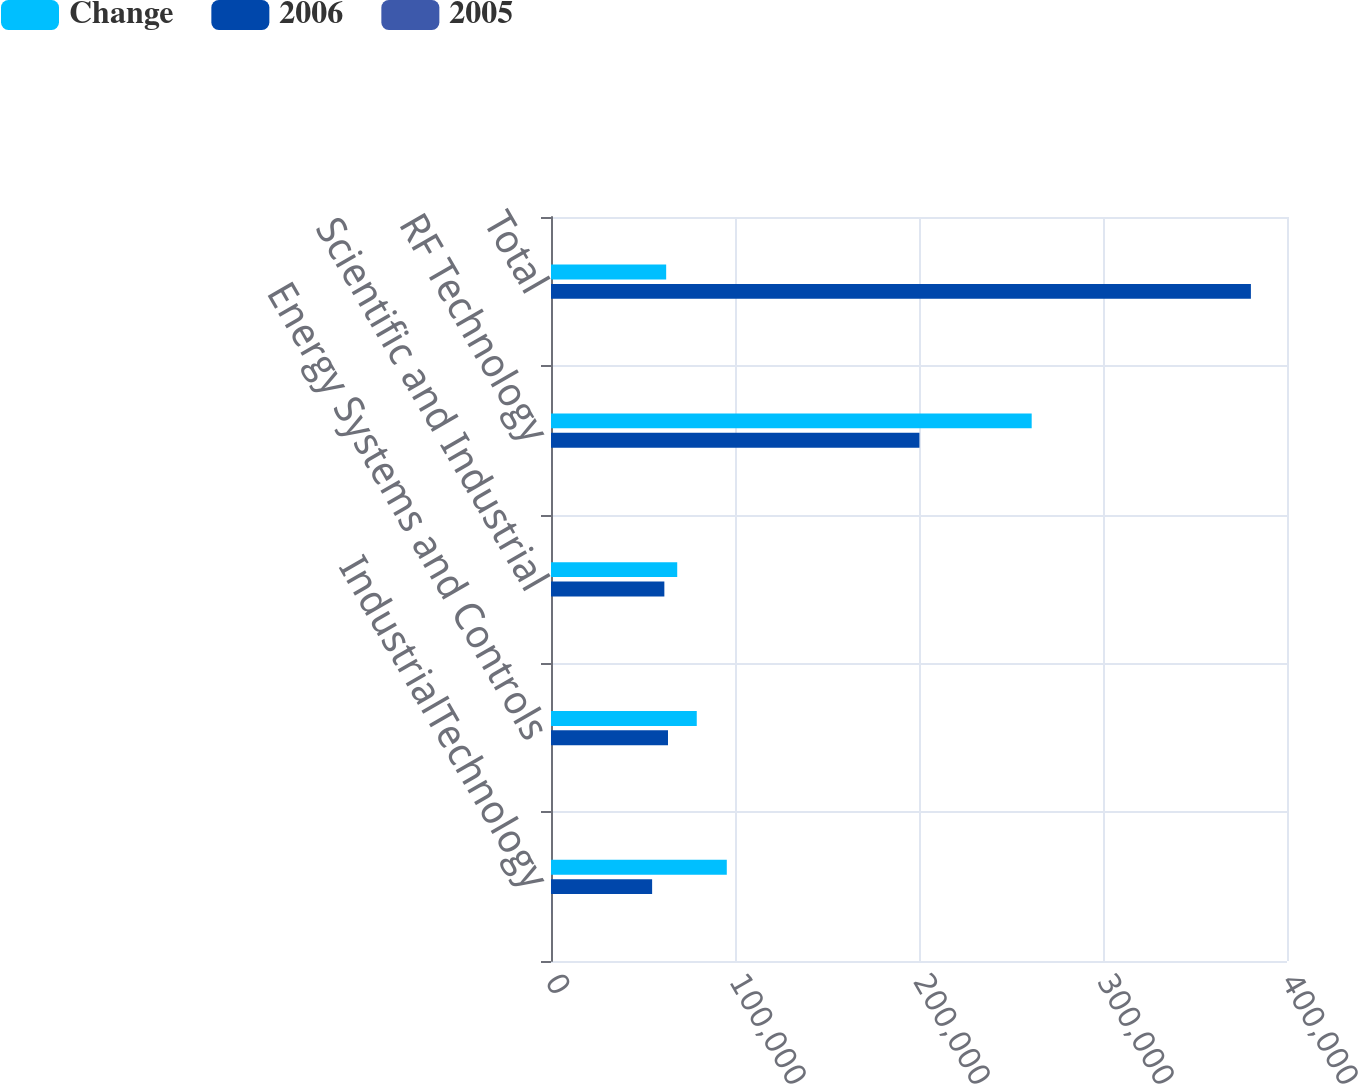Convert chart to OTSL. <chart><loc_0><loc_0><loc_500><loc_500><stacked_bar_chart><ecel><fcel>IndustrialTechnology<fcel>Energy Systems and Controls<fcel>Scientific and Industrial<fcel>RF Technology<fcel>Total<nl><fcel>Change<fcel>95539<fcel>79217<fcel>68600<fcel>261243<fcel>62594.5<nl><fcel>2006<fcel>54959<fcel>63583<fcel>61606<fcel>200233<fcel>380381<nl><fcel>2005<fcel>73.8<fcel>24.6<fcel>11.4<fcel>30.5<fcel>32.7<nl></chart> 